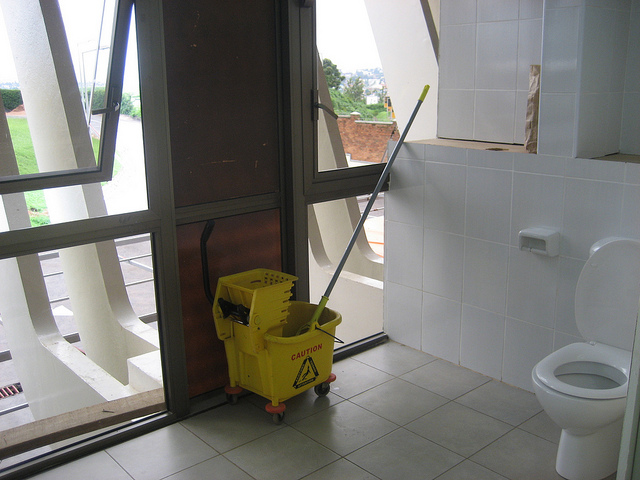Extract all visible text content from this image. CAUTION 